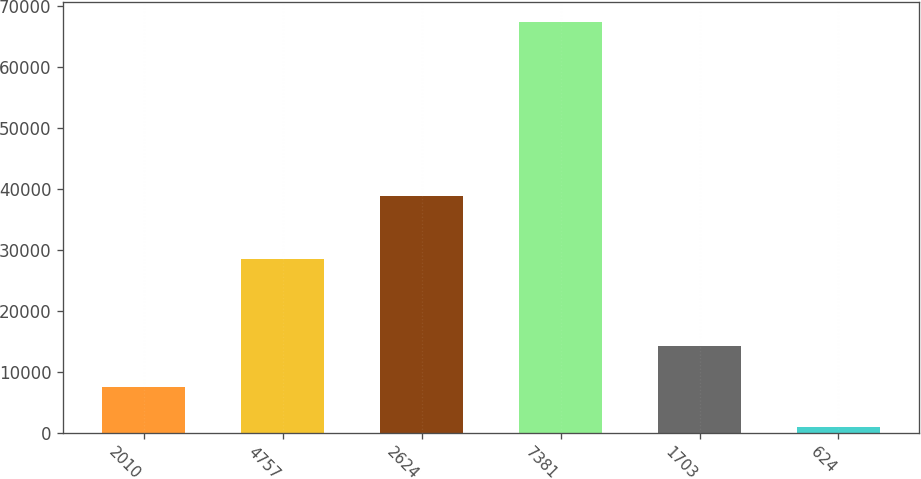Convert chart to OTSL. <chart><loc_0><loc_0><loc_500><loc_500><bar_chart><fcel>2010<fcel>4757<fcel>2624<fcel>7381<fcel>1703<fcel>624<nl><fcel>7558.6<fcel>28473<fcel>38779<fcel>67252<fcel>14191.2<fcel>926<nl></chart> 